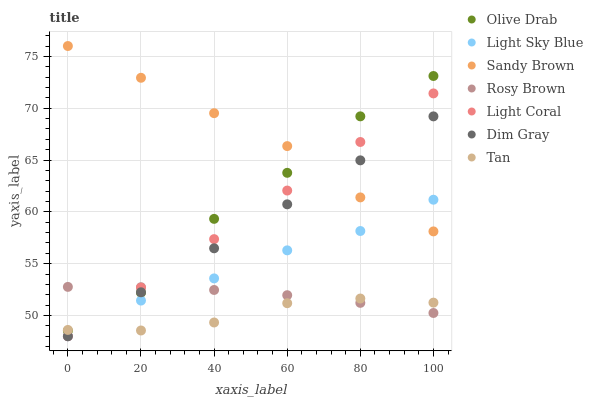Does Tan have the minimum area under the curve?
Answer yes or no. Yes. Does Sandy Brown have the maximum area under the curve?
Answer yes or no. Yes. Does Rosy Brown have the minimum area under the curve?
Answer yes or no. No. Does Rosy Brown have the maximum area under the curve?
Answer yes or no. No. Is Dim Gray the smoothest?
Answer yes or no. Yes. Is Olive Drab the roughest?
Answer yes or no. Yes. Is Rosy Brown the smoothest?
Answer yes or no. No. Is Rosy Brown the roughest?
Answer yes or no. No. Does Dim Gray have the lowest value?
Answer yes or no. Yes. Does Rosy Brown have the lowest value?
Answer yes or no. No. Does Sandy Brown have the highest value?
Answer yes or no. Yes. Does Rosy Brown have the highest value?
Answer yes or no. No. Is Rosy Brown less than Sandy Brown?
Answer yes or no. Yes. Is Olive Drab greater than Light Sky Blue?
Answer yes or no. Yes. Does Dim Gray intersect Rosy Brown?
Answer yes or no. Yes. Is Dim Gray less than Rosy Brown?
Answer yes or no. No. Is Dim Gray greater than Rosy Brown?
Answer yes or no. No. Does Rosy Brown intersect Sandy Brown?
Answer yes or no. No. 